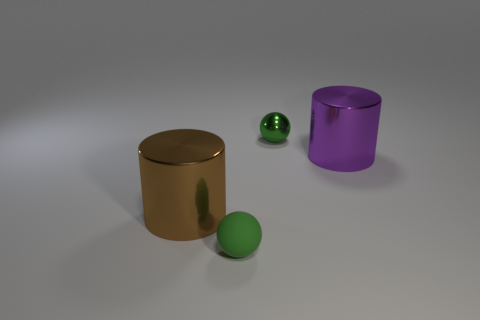How many big cylinders are in front of the big thing that is on the left side of the big shiny thing that is on the right side of the small shiny object?
Your answer should be very brief. 0. The large purple metal thing is what shape?
Provide a succinct answer. Cylinder. Does the green rubber object have the same size as the brown cylinder?
Give a very brief answer. No. The big metal object on the right side of the brown thing has what shape?
Offer a terse response. Cylinder. What color is the sphere that is right of the green thing that is left of the small shiny object?
Your answer should be very brief. Green. Do the green object to the left of the green shiny thing and the large metal thing right of the tiny green matte sphere have the same shape?
Ensure brevity in your answer.  No. What is the shape of the purple thing that is the same size as the brown cylinder?
Your answer should be compact. Cylinder. The large cylinder that is made of the same material as the large purple thing is what color?
Your answer should be very brief. Brown. There is a tiny matte object; does it have the same shape as the thing that is left of the green rubber sphere?
Your answer should be compact. No. There is a sphere that is the same color as the matte object; what material is it?
Offer a very short reply. Metal. 